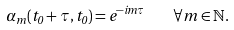<formula> <loc_0><loc_0><loc_500><loc_500>\alpha _ { m } ( t _ { 0 } + \tau , t _ { 0 } ) = e ^ { - i m \tau } \quad \forall m \in \mathbb { N } .</formula> 